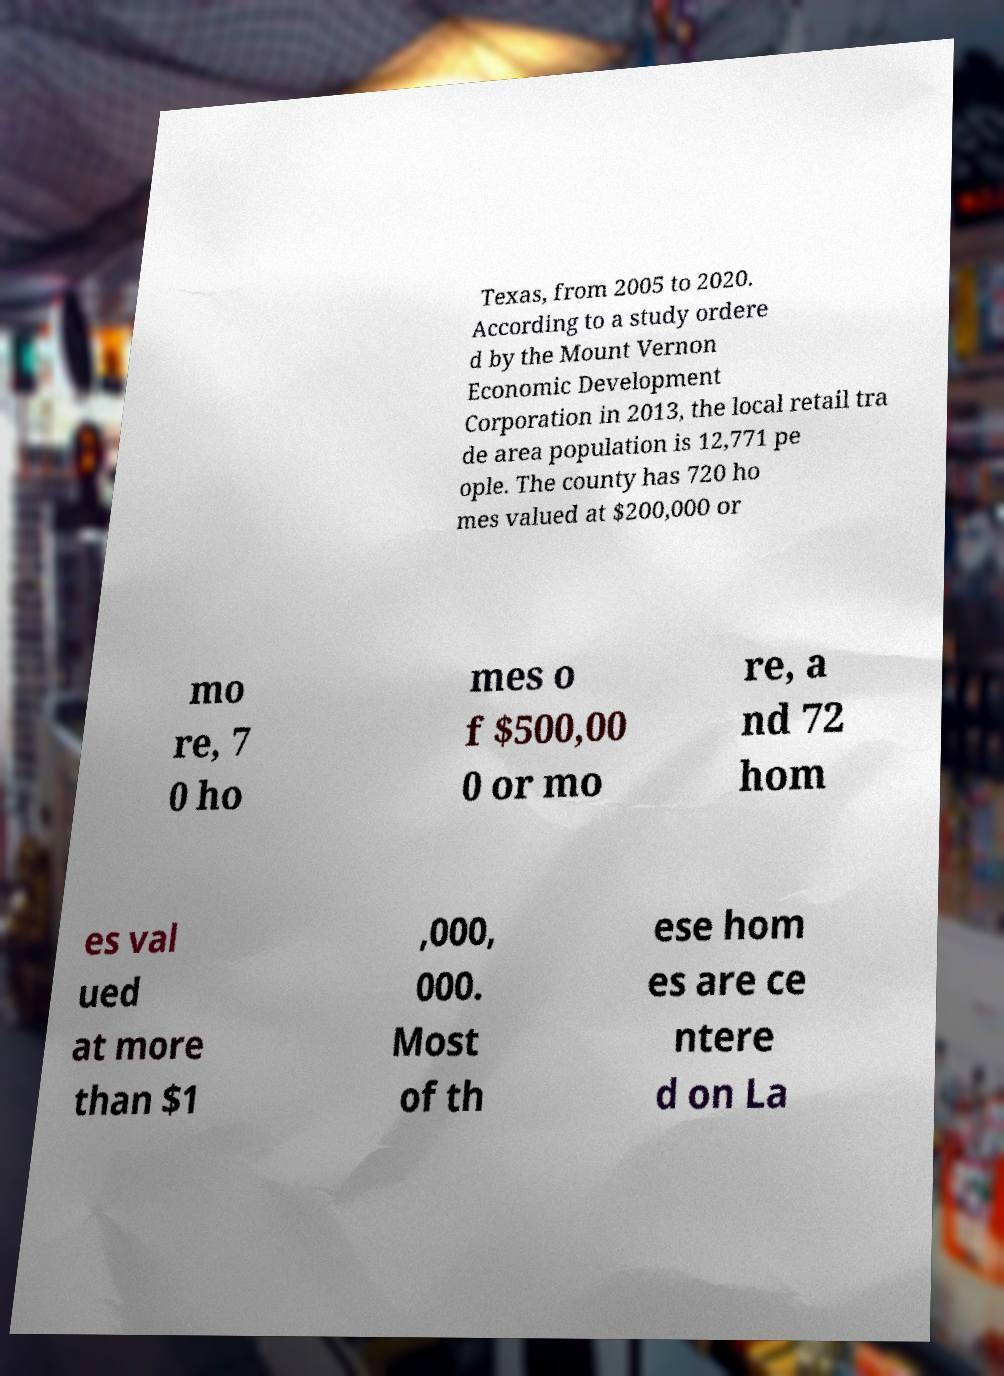I need the written content from this picture converted into text. Can you do that? Texas, from 2005 to 2020. According to a study ordere d by the Mount Vernon Economic Development Corporation in 2013, the local retail tra de area population is 12,771 pe ople. The county has 720 ho mes valued at $200,000 or mo re, 7 0 ho mes o f $500,00 0 or mo re, a nd 72 hom es val ued at more than $1 ,000, 000. Most of th ese hom es are ce ntere d on La 